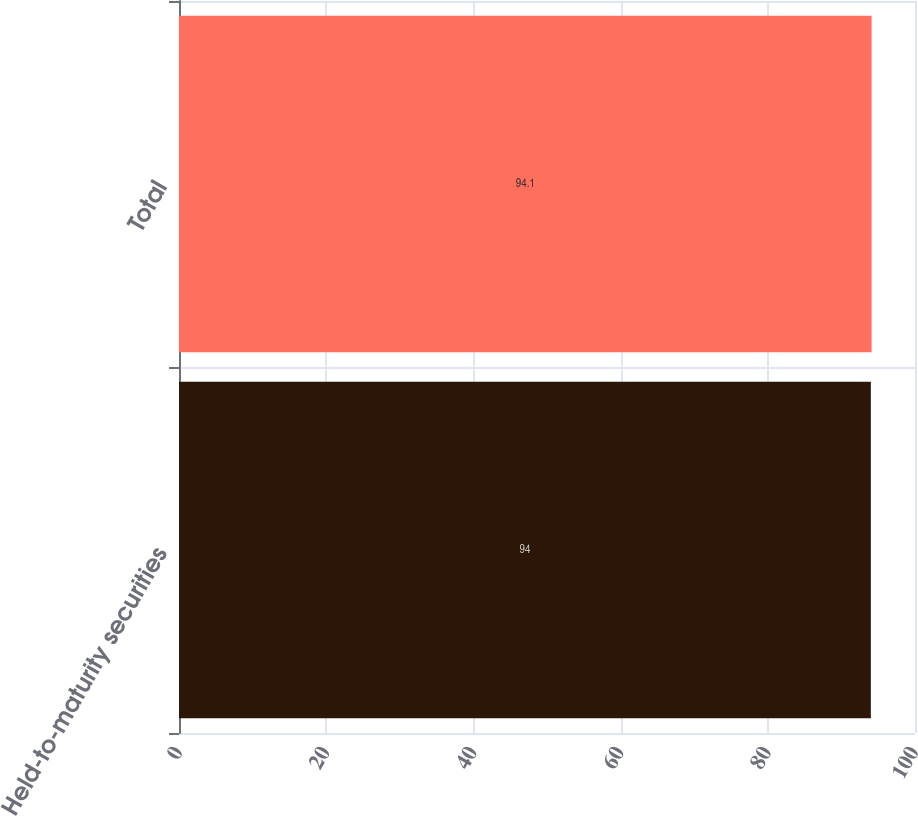Convert chart. <chart><loc_0><loc_0><loc_500><loc_500><bar_chart><fcel>Held-to-maturity securities<fcel>Total<nl><fcel>94<fcel>94.1<nl></chart> 